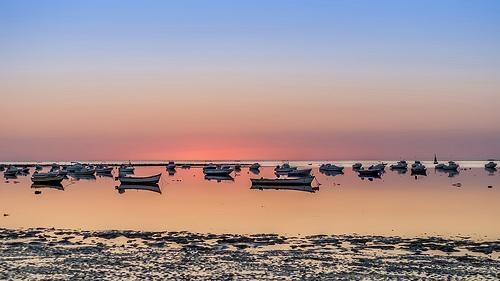How many boats are closest to the shore?
Give a very brief answer. 3. 